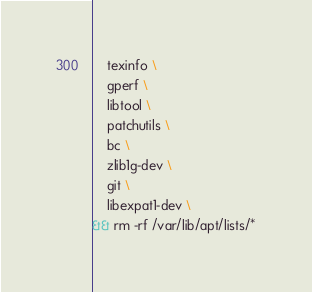<code> <loc_0><loc_0><loc_500><loc_500><_Dockerfile_>    texinfo \
    gperf \
    libtool \
    patchutils \
    bc \
    zlib1g-dev \
    git \
    libexpat1-dev \
&& rm -rf /var/lib/apt/lists/*
</code> 